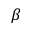<formula> <loc_0><loc_0><loc_500><loc_500>\beta</formula> 